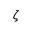Convert formula to latex. <formula><loc_0><loc_0><loc_500><loc_500>\zeta</formula> 